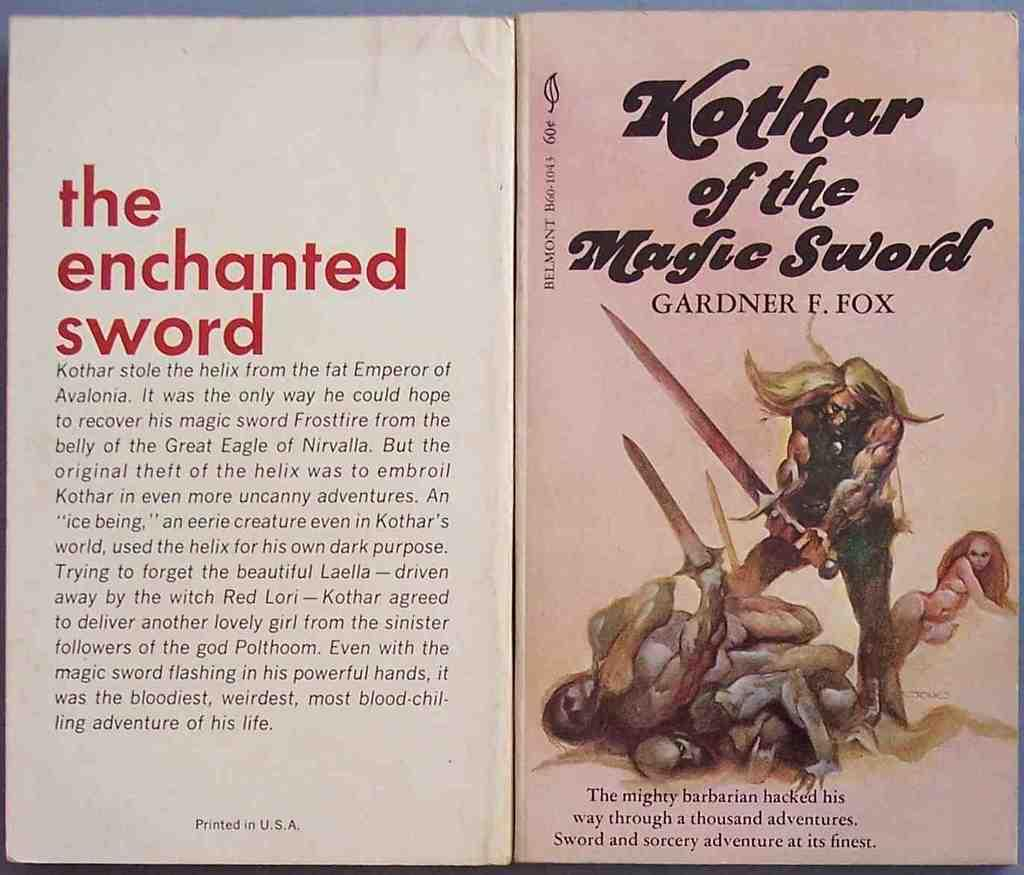<image>
Write a terse but informative summary of the picture. Gardner F. Fox wrote the Kothar of the Magic Sword. 